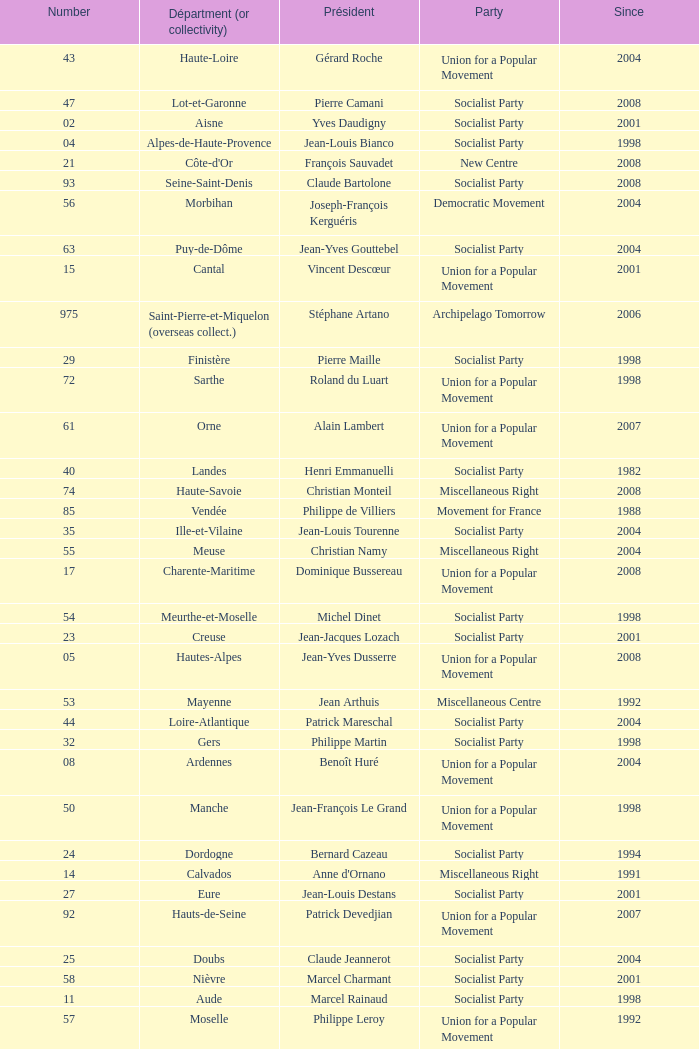Who is the president representing the Creuse department? Jean-Jacques Lozach. 